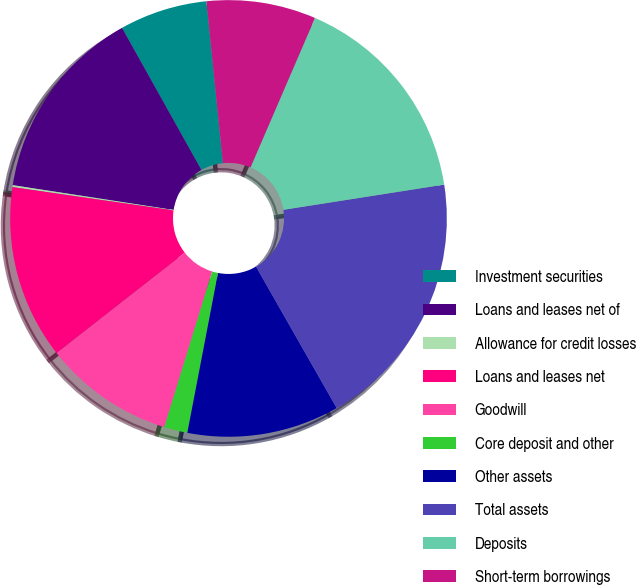<chart> <loc_0><loc_0><loc_500><loc_500><pie_chart><fcel>Investment securities<fcel>Loans and leases net of<fcel>Allowance for credit losses<fcel>Loans and leases net<fcel>Goodwill<fcel>Core deposit and other<fcel>Other assets<fcel>Total assets<fcel>Deposits<fcel>Short-term borrowings<nl><fcel>6.5%<fcel>14.45%<fcel>0.14%<fcel>12.86%<fcel>9.68%<fcel>1.73%<fcel>11.27%<fcel>19.22%<fcel>16.04%<fcel>8.09%<nl></chart> 